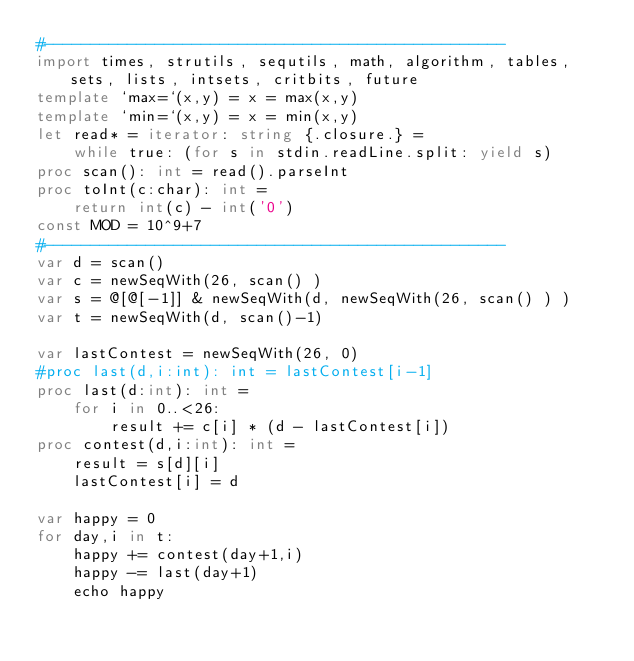<code> <loc_0><loc_0><loc_500><loc_500><_Nim_>#--------------------------------------------------
import times, strutils, sequtils, math, algorithm, tables, sets, lists, intsets, critbits, future
template `max=`(x,y) = x = max(x,y)
template `min=`(x,y) = x = min(x,y)
let read* = iterator: string {.closure.} =
    while true: (for s in stdin.readLine.split: yield s)
proc scan(): int = read().parseInt
proc toInt(c:char): int =
    return int(c) - int('0')
const MOD = 10^9+7
#--------------------------------------------------
var d = scan()
var c = newSeqWith(26, scan() )
var s = @[@[-1]] & newSeqWith(d, newSeqWith(26, scan() ) )
var t = newSeqWith(d, scan()-1)

var lastContest = newSeqWith(26, 0)
#proc last(d,i:int): int = lastContest[i-1]
proc last(d:int): int =
    for i in 0..<26:
        result += c[i] * (d - lastContest[i])
proc contest(d,i:int): int =
    result = s[d][i]
    lastContest[i] = d

var happy = 0
for day,i in t:
    happy += contest(day+1,i)
    happy -= last(day+1)
    echo happy</code> 